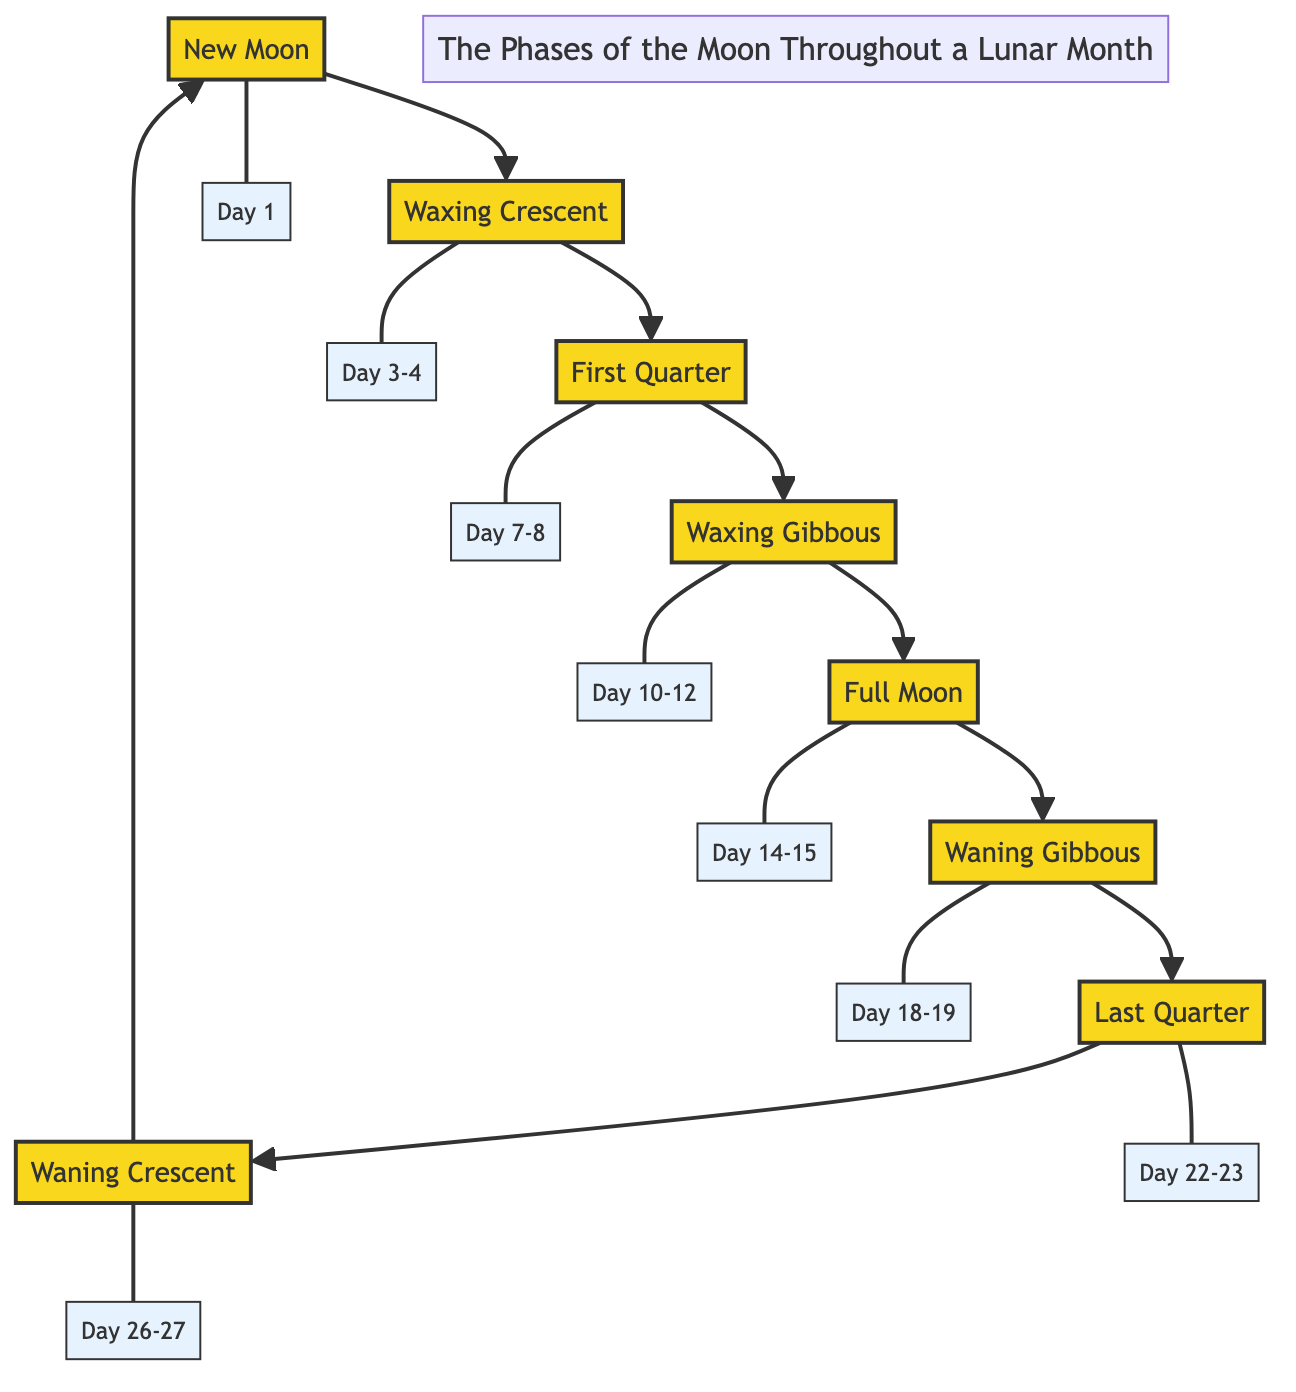What is the first phase of the moon? The diagram starts with "New Moon" as the first phase. It is the initial point in the sequence of the lunar phases.
Answer: New Moon How many phases are depicted in the diagram? The diagram illustrates 8 different phases of the moon, which can be counted from New Moon through to Waning Crescent.
Answer: 8 What dates correspond to the Full Moon? The diagram shows "Day 14-15" next to the phase "Full Moon" indicating those dates correspond to this phase.
Answer: Day 14-15 What phase comes directly after the First Quarter? According to the diagram's sequence, the phase that follows "First Quarter" is "Waxing Gibbous". This can be observed by following the directional flow from First Quarter to Waxing Gibbous.
Answer: Waxing Gibbous Which phase appears on Day 22-23? By looking at the date associated with the phases, "Day 22-23" corresponds to the phase "Last Quarter". This can be confirmed by tracing the arrows connecting dates to their respective phases.
Answer: Last Quarter What is the last phase before returning to New Moon? The last phase in the lunar sequence before cycling back to New Moon is "Waning Crescent". This can be determined by following the flow of phases around the diagram.
Answer: Waning Crescent How many days does it take for the moon to go from Full Moon to New Moon? The duration from the Full Moon phase (Day 14-15) to the New Moon phase (Day 1) spans 13-14 days, which includes the phases of Waning Gibbous, Last Quarter, and Waning Crescent in between. This can be calculated by examining the timeline of phases.
Answer: 13-14 days What is the date range for the Waxing Gibbous phase? The diagram indicates that "Waxing Gibbous" is represented by "Day 10-12", which directly provides the specific date range for this phase.
Answer: Day 10-12 